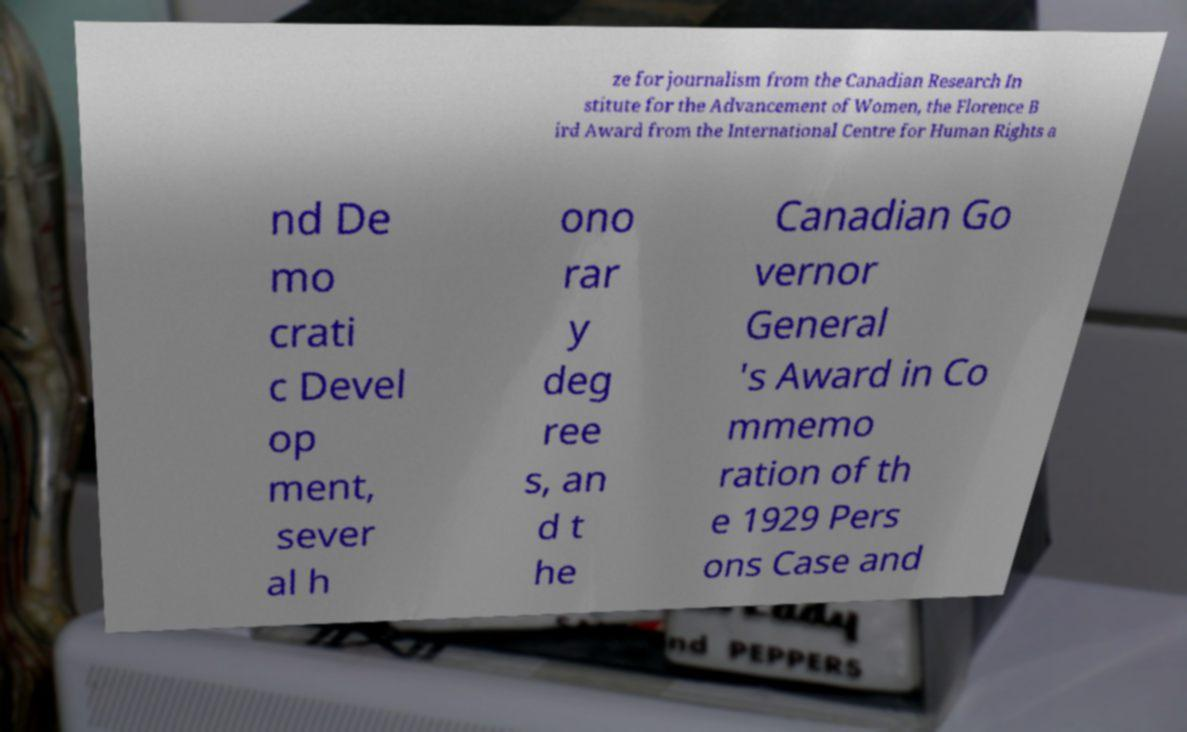Please read and relay the text visible in this image. What does it say? ze for journalism from the Canadian Research In stitute for the Advancement of Women, the Florence B ird Award from the International Centre for Human Rights a nd De mo crati c Devel op ment, sever al h ono rar y deg ree s, an d t he Canadian Go vernor General 's Award in Co mmemo ration of th e 1929 Pers ons Case and 